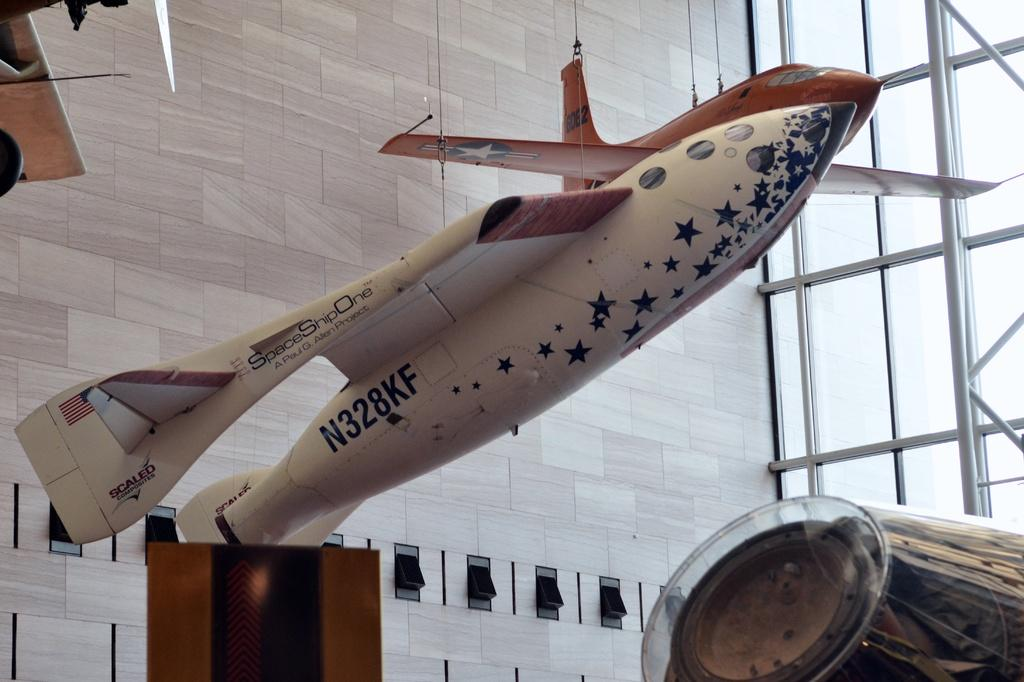<image>
Give a short and clear explanation of the subsequent image. An airplane is in a building with the marking N328KF on the side of it. 